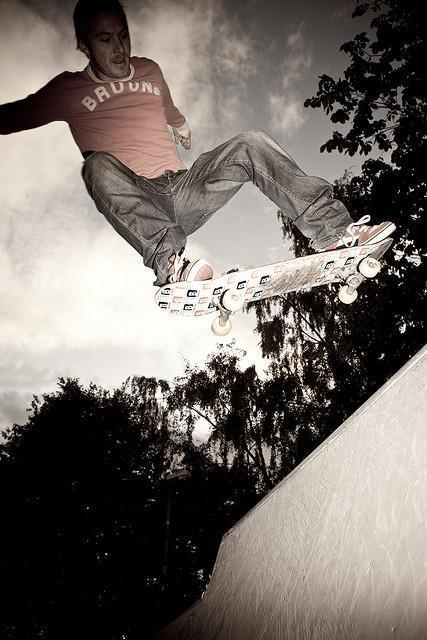How many feet are touching the skateboard?
Give a very brief answer. 2. 